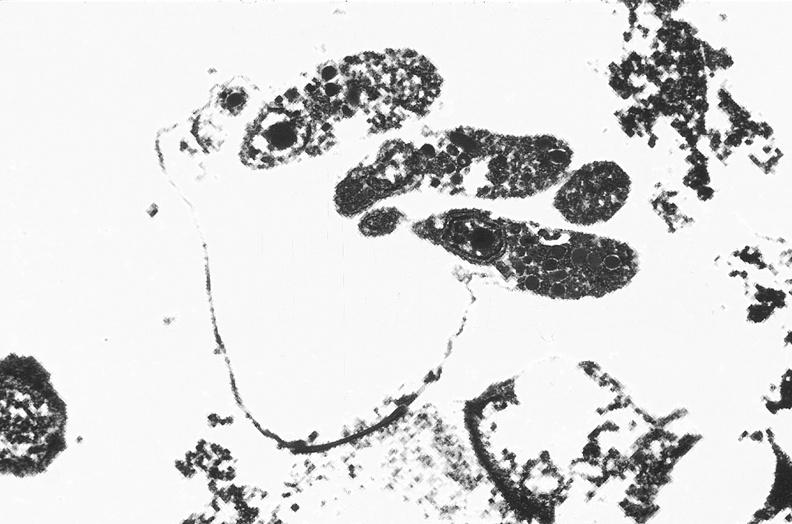where is this electron microscopy figure taken?
Answer the question using a single word or phrase. Gastrointestinal system 